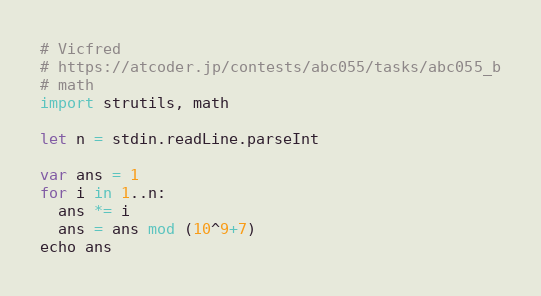Convert code to text. <code><loc_0><loc_0><loc_500><loc_500><_Nim_># Vicfred
# https://atcoder.jp/contests/abc055/tasks/abc055_b
# math
import strutils, math

let n = stdin.readLine.parseInt

var ans = 1
for i in 1..n:
  ans *= i
  ans = ans mod (10^9+7)
echo ans

</code> 